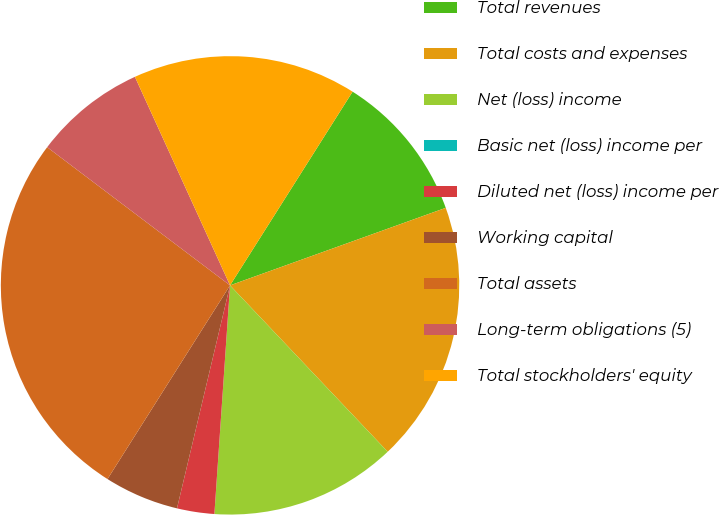<chart> <loc_0><loc_0><loc_500><loc_500><pie_chart><fcel>Total revenues<fcel>Total costs and expenses<fcel>Net (loss) income<fcel>Basic net (loss) income per<fcel>Diluted net (loss) income per<fcel>Working capital<fcel>Total assets<fcel>Long-term obligations (5)<fcel>Total stockholders' equity<nl><fcel>10.53%<fcel>18.42%<fcel>13.16%<fcel>0.0%<fcel>2.63%<fcel>5.26%<fcel>26.32%<fcel>7.89%<fcel>15.79%<nl></chart> 